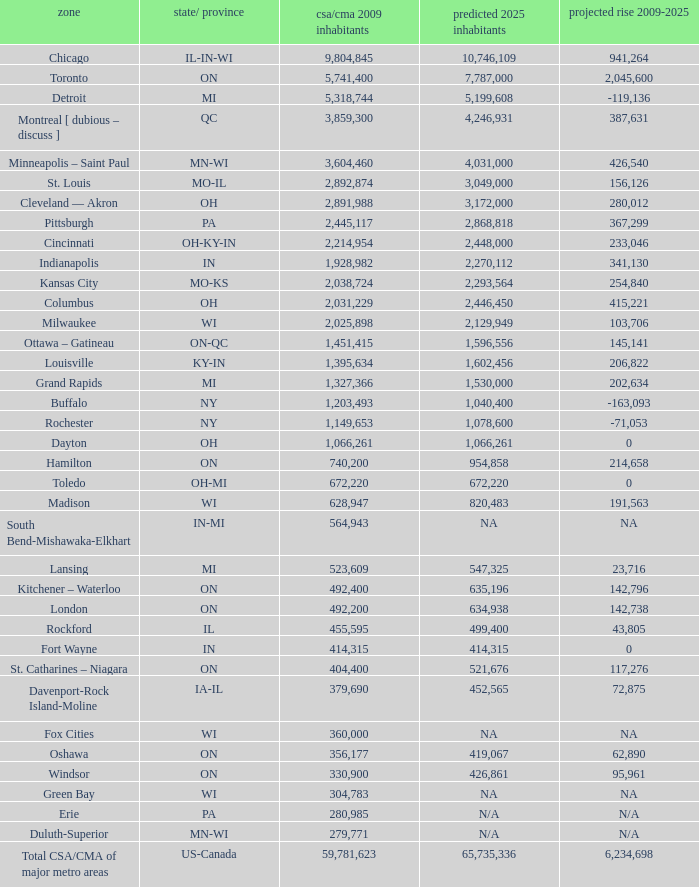What's the projected population of IN-MI? NA. 